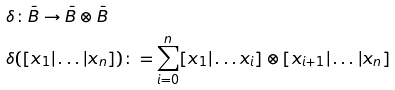Convert formula to latex. <formula><loc_0><loc_0><loc_500><loc_500>& \delta \colon \bar { B } \to \bar { B } \otimes \bar { B } \\ & \delta ( [ x _ { 1 } | \dots | x _ { n } ] ) \colon = \sum _ { i = 0 } ^ { n } [ x _ { 1 } | \dots x _ { i } ] \otimes [ x _ { i + 1 } | \dots | x _ { n } ]</formula> 